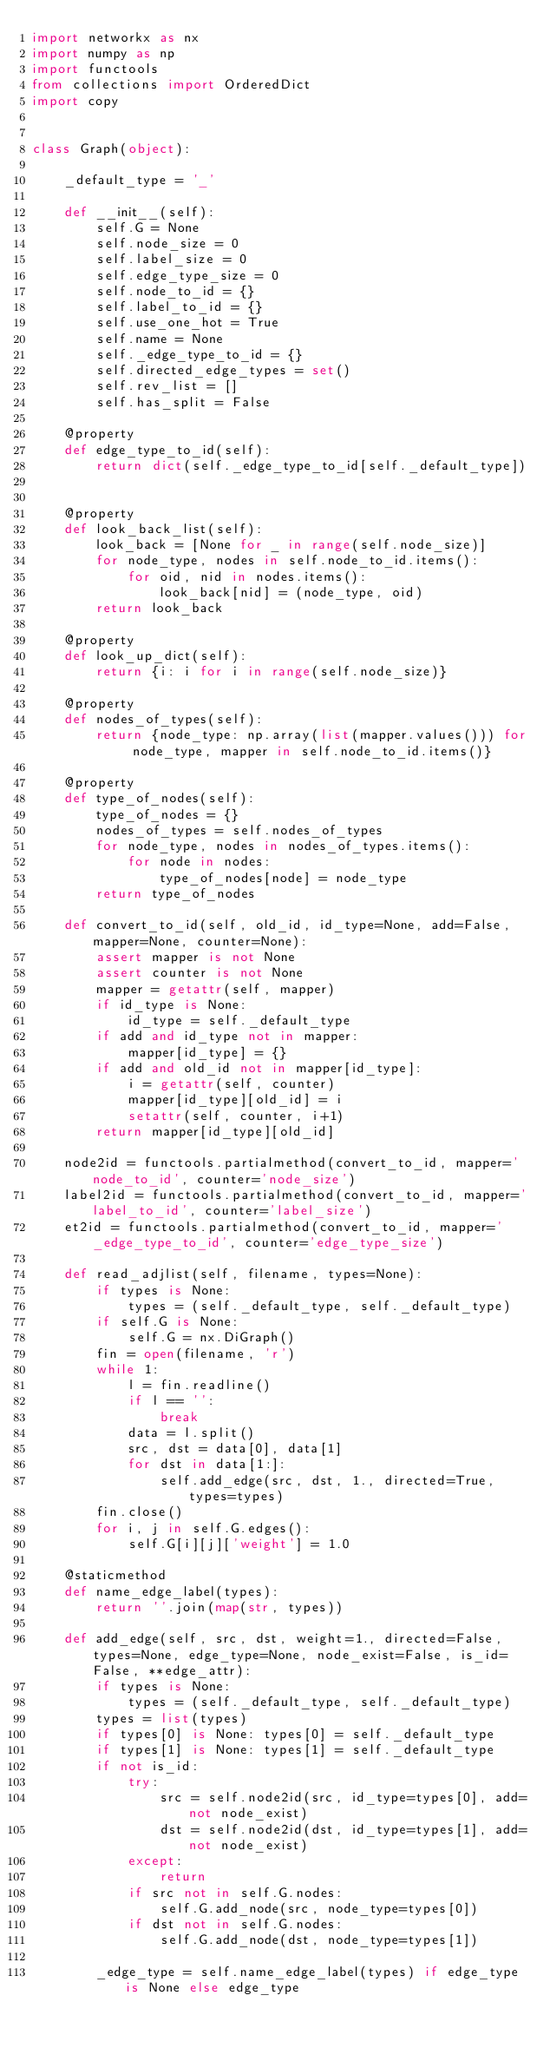<code> <loc_0><loc_0><loc_500><loc_500><_Python_>import networkx as nx
import numpy as np
import functools
from collections import OrderedDict
import copy


class Graph(object):

    _default_type = '_'

    def __init__(self):
        self.G = None
        self.node_size = 0
        self.label_size = 0
        self.edge_type_size = 0
        self.node_to_id = {}
        self.label_to_id = {}
        self.use_one_hot = True
        self.name = None
        self._edge_type_to_id = {}
        self.directed_edge_types = set()
        self.rev_list = []
        self.has_split = False

    @property
    def edge_type_to_id(self):
        return dict(self._edge_type_to_id[self._default_type])


    @property
    def look_back_list(self):
        look_back = [None for _ in range(self.node_size)]
        for node_type, nodes in self.node_to_id.items():
            for oid, nid in nodes.items():
                look_back[nid] = (node_type, oid)
        return look_back

    @property
    def look_up_dict(self):
        return {i: i for i in range(self.node_size)}

    @property
    def nodes_of_types(self):
        return {node_type: np.array(list(mapper.values())) for node_type, mapper in self.node_to_id.items()}

    @property
    def type_of_nodes(self):
        type_of_nodes = {}
        nodes_of_types = self.nodes_of_types
        for node_type, nodes in nodes_of_types.items():
            for node in nodes:
                type_of_nodes[node] = node_type
        return type_of_nodes

    def convert_to_id(self, old_id, id_type=None, add=False, mapper=None, counter=None):
        assert mapper is not None
        assert counter is not None
        mapper = getattr(self, mapper)
        if id_type is None:
            id_type = self._default_type
        if add and id_type not in mapper:
            mapper[id_type] = {}
        if add and old_id not in mapper[id_type]:
            i = getattr(self, counter)
            mapper[id_type][old_id] = i
            setattr(self, counter, i+1)
        return mapper[id_type][old_id]

    node2id = functools.partialmethod(convert_to_id, mapper='node_to_id', counter='node_size')
    label2id = functools.partialmethod(convert_to_id, mapper='label_to_id', counter='label_size')
    et2id = functools.partialmethod(convert_to_id, mapper='_edge_type_to_id', counter='edge_type_size')

    def read_adjlist(self, filename, types=None):
        if types is None:
            types = (self._default_type, self._default_type)
        if self.G is None:
            self.G = nx.DiGraph()
        fin = open(filename, 'r')
        while 1:
            l = fin.readline()
            if l == '':
                break
            data = l.split()
            src, dst = data[0], data[1]
            for dst in data[1:]:
                self.add_edge(src, dst, 1., directed=True, types=types)
        fin.close()
        for i, j in self.G.edges():
            self.G[i][j]['weight'] = 1.0

    @staticmethod
    def name_edge_label(types):
        return ''.join(map(str, types))

    def add_edge(self, src, dst, weight=1., directed=False, types=None, edge_type=None, node_exist=False, is_id=False, **edge_attr):
        if types is None:
            types = (self._default_type, self._default_type)
        types = list(types)
        if types[0] is None: types[0] = self._default_type
        if types[1] is None: types[1] = self._default_type
        if not is_id:
            try:
                src = self.node2id(src, id_type=types[0], add=not node_exist)
                dst = self.node2id(dst, id_type=types[1], add=not node_exist)
            except:
                return
            if src not in self.G.nodes:
                self.G.add_node(src, node_type=types[0])
            if dst not in self.G.nodes:
                self.G.add_node(dst, node_type=types[1])

        _edge_type = self.name_edge_label(types) if edge_type is None else edge_type</code> 